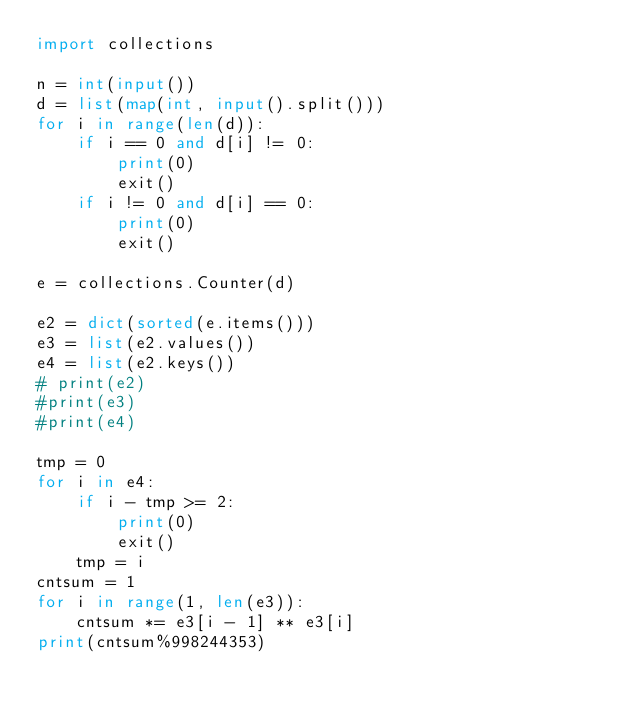Convert code to text. <code><loc_0><loc_0><loc_500><loc_500><_Python_>import collections
 
n = int(input())
d = list(map(int, input().split()))
for i in range(len(d)):
    if i == 0 and d[i] != 0:
        print(0)
        exit()
    if i != 0 and d[i] == 0:
        print(0)
        exit()
 
e = collections.Counter(d)
 
e2 = dict(sorted(e.items()))
e3 = list(e2.values())
e4 = list(e2.keys())
# print(e2)
#print(e3)
#print(e4)
 
tmp = 0
for i in e4:
    if i - tmp >= 2:
        print(0)
        exit()
    tmp = i
cntsum = 1
for i in range(1, len(e3)):
    cntsum *= e3[i - 1] ** e3[i]
print(cntsum%998244353)</code> 